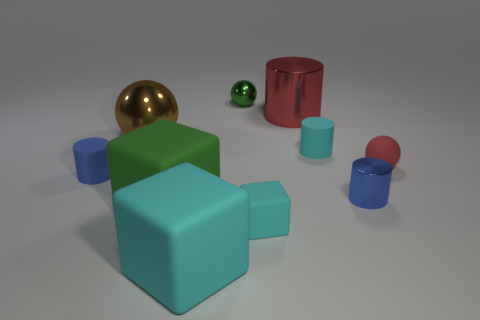There is a ball in front of the brown object; is its color the same as the large cylinder? Yes, the ball in front of the brown object has the same vibrant red color as the large cylinder on the right, reflecting a consistency in hue and saturation between the two items in the image. 